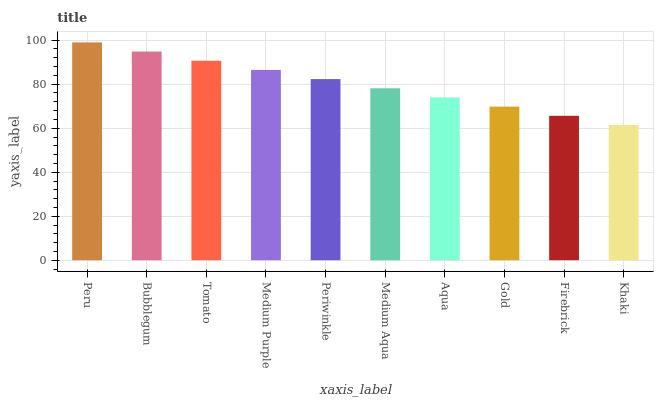Is Khaki the minimum?
Answer yes or no. Yes. Is Peru the maximum?
Answer yes or no. Yes. Is Bubblegum the minimum?
Answer yes or no. No. Is Bubblegum the maximum?
Answer yes or no. No. Is Peru greater than Bubblegum?
Answer yes or no. Yes. Is Bubblegum less than Peru?
Answer yes or no. Yes. Is Bubblegum greater than Peru?
Answer yes or no. No. Is Peru less than Bubblegum?
Answer yes or no. No. Is Periwinkle the high median?
Answer yes or no. Yes. Is Medium Aqua the low median?
Answer yes or no. Yes. Is Aqua the high median?
Answer yes or no. No. Is Periwinkle the low median?
Answer yes or no. No. 